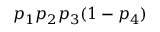<formula> <loc_0><loc_0><loc_500><loc_500>p _ { 1 } p _ { 2 } p _ { 3 } ( 1 - p _ { 4 } )</formula> 